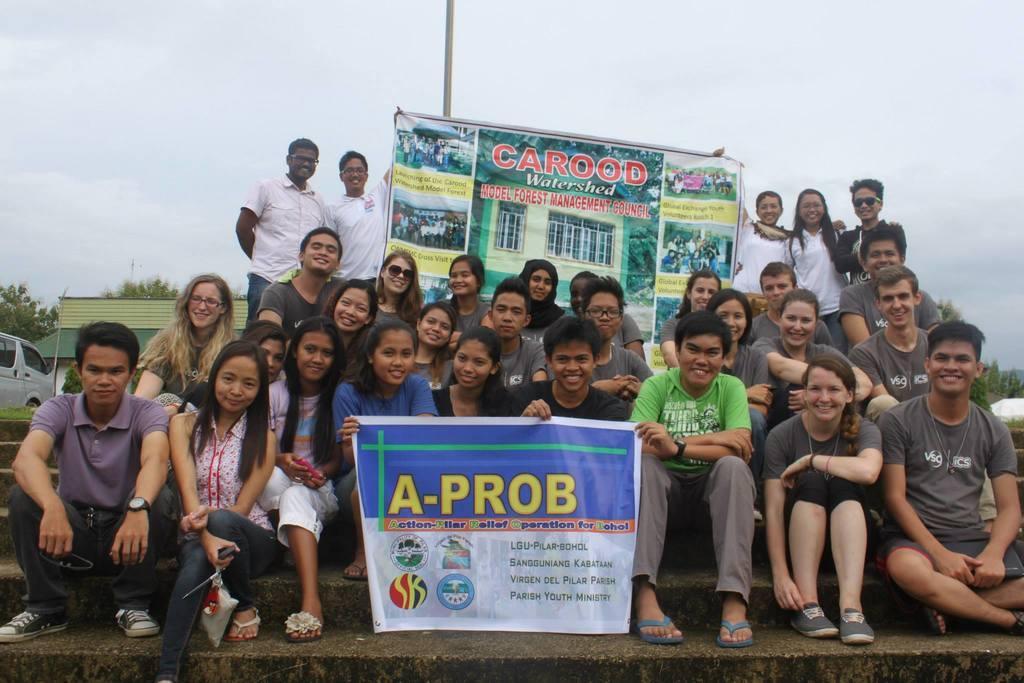How would you summarize this image in a sentence or two? As we can see in the image there are group of people over here, banners, car, trees and a house. On the top there is a sky. 